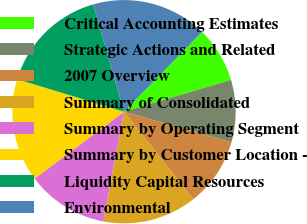Convert chart. <chart><loc_0><loc_0><loc_500><loc_500><pie_chart><fcel>Critical Accounting Estimates<fcel>Strategic Actions and Related<fcel>2007 Overview<fcel>Summary of Consolidated<fcel>Summary by Operating Segment<fcel>Summary by Customer Location -<fcel>Liquidity Capital Resources<fcel>Environmental<nl><fcel>8.07%<fcel>9.0%<fcel>9.93%<fcel>13.65%<fcel>11.79%<fcel>14.92%<fcel>15.85%<fcel>16.78%<nl></chart> 